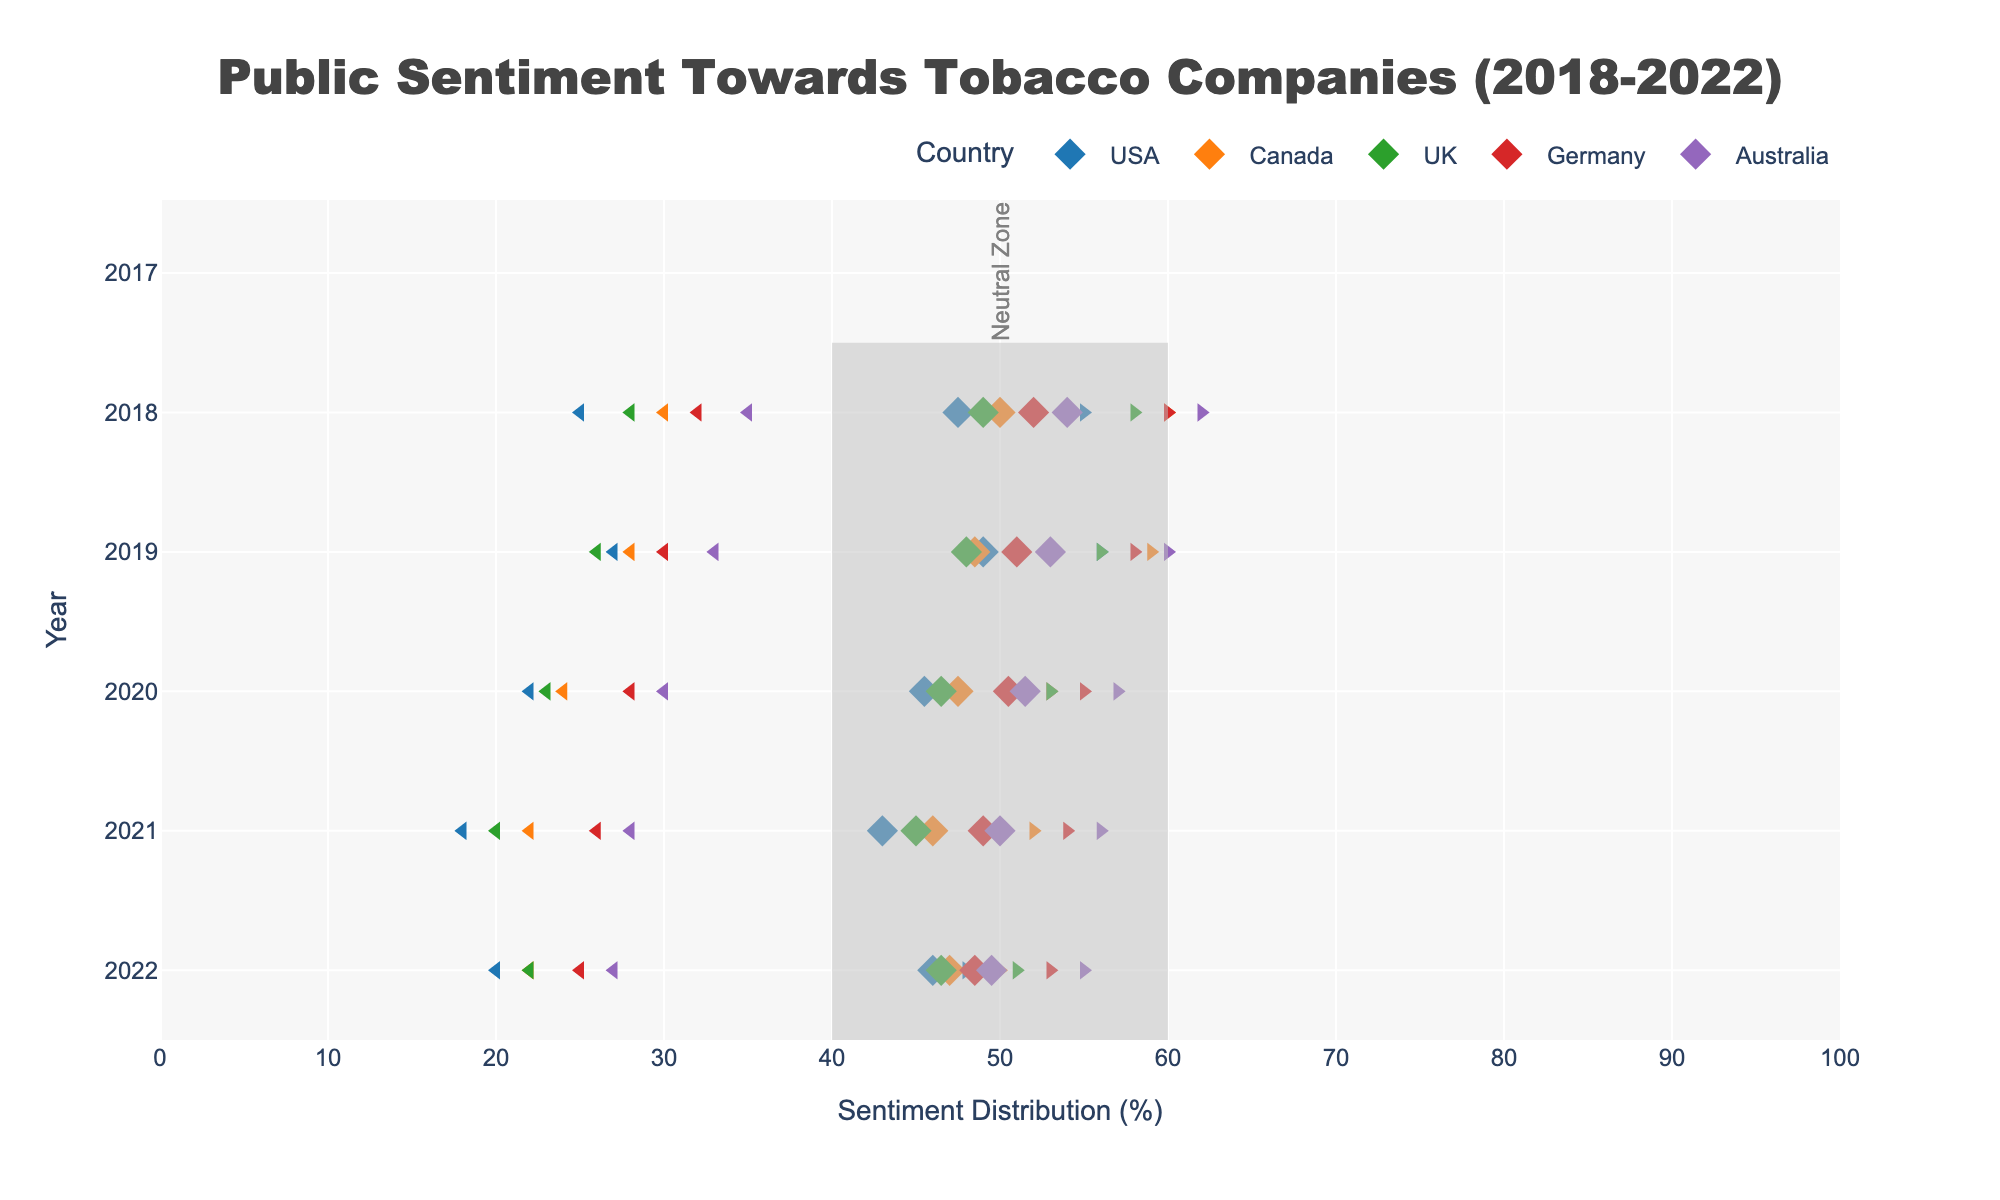What is the overall trend in positive sentiment towards tobacco companies in the USA from 2018 to 2022? The plot shows markers representing positive sentiment for each year. For the USA, the positive sentiment starts at 25% in 2018 and decreases to around 20% in 2022, with some fluctuations in between.
Answer: Decreasing What color is used for representing Australia? In the plot, each country is represented by a different color. The color used for Australia is a unique, recognizable purple shade.
Answer: Purple In which year did Canada have exactly 50% neutral sentiment? To find this, look at the neutral sentiment values for Canada. The plot shows that in 2022, Canada has a neutral sentiment value of 50%.
Answer: 2022 Which country had the highest positive sentiment in 2018? Examine the positive sentiment markers for the year 2018. Australia has the highest marker at 35% in 2018 compared to other countries.
Answer: Australia What was the range of negative sentiment in the UK from 2018 to 2022? Find the minimum and maximum values of negative sentiment in the UK by looking at the data points. Between 2018 to 2022, negative sentiment in the UK ranged from 29% to 30%.
Answer: 29%-30% How does the range of positive sentiment in Germany compare to that in the UK over the years? Identify the smallest and largest positive sentiment values for both countries from 2018-2022. Germany's range is from 25% to 32%, whereas the UK's range is 20% to 28%. Comparatively, Germany's range is slightly higher.
Answer: Germany's range is higher What is the difference in neutral sentiment between the UK and USA in 2022? Identify the neutral sentiment for both the UK and USA in 2022 and subtract the USA value from the UK value. The neutral sentiment in 2022 is 49% for the UK and 52% for the USA. Hence, the difference is 3%.
Answer: 3% Which country exhibits the most stability in their neutral sentiment from 2018 to 2022? Examine the neutral sentiment markers for each country over the years. Germany's neutral sentiment shows less variation compared to other countries, remaining close to 40-47%.
Answer: Germany In 2020, which country had the lowest midpoint value in positive and neutral sentiment combined? Calculate or find the midpoint value for 2020 by averaging the positive sentiment and half of the neutral sentiment for each country. The USA has the lowest midpoint value in 2020, which is around 22% positive + 23.5% (half of 47%) neutral = 45.5%.
Answer: USA 